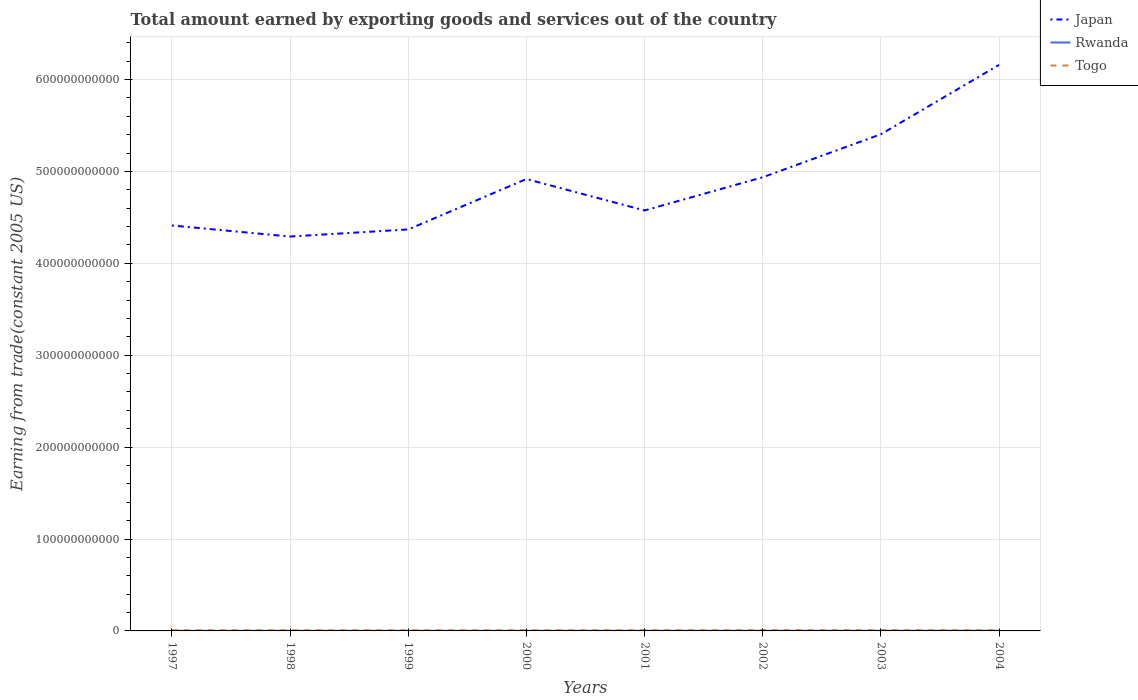How many different coloured lines are there?
Keep it short and to the point. 3. Is the number of lines equal to the number of legend labels?
Your answer should be very brief. Yes. Across all years, what is the maximum total amount earned by exporting goods and services in Togo?
Your response must be concise. 7.16e+08. What is the total total amount earned by exporting goods and services in Japan in the graph?
Your response must be concise. -5.68e+1. What is the difference between the highest and the second highest total amount earned by exporting goods and services in Rwanda?
Make the answer very short. 1.30e+08. Is the total amount earned by exporting goods and services in Rwanda strictly greater than the total amount earned by exporting goods and services in Japan over the years?
Provide a short and direct response. Yes. What is the difference between two consecutive major ticks on the Y-axis?
Provide a succinct answer. 1.00e+11. Does the graph contain grids?
Give a very brief answer. Yes. How are the legend labels stacked?
Offer a very short reply. Vertical. What is the title of the graph?
Offer a very short reply. Total amount earned by exporting goods and services out of the country. Does "Jordan" appear as one of the legend labels in the graph?
Keep it short and to the point. No. What is the label or title of the X-axis?
Keep it short and to the point. Years. What is the label or title of the Y-axis?
Offer a terse response. Earning from trade(constant 2005 US). What is the Earning from trade(constant 2005 US) of Japan in 1997?
Provide a succinct answer. 4.41e+11. What is the Earning from trade(constant 2005 US) of Rwanda in 1997?
Offer a very short reply. 7.58e+07. What is the Earning from trade(constant 2005 US) in Togo in 1997?
Provide a succinct answer. 7.65e+08. What is the Earning from trade(constant 2005 US) of Japan in 1998?
Give a very brief answer. 4.29e+11. What is the Earning from trade(constant 2005 US) in Rwanda in 1998?
Make the answer very short. 7.73e+07. What is the Earning from trade(constant 2005 US) of Togo in 1998?
Give a very brief answer. 7.56e+08. What is the Earning from trade(constant 2005 US) of Japan in 1999?
Offer a terse response. 4.37e+11. What is the Earning from trade(constant 2005 US) of Rwanda in 1999?
Your response must be concise. 9.19e+07. What is the Earning from trade(constant 2005 US) of Togo in 1999?
Give a very brief answer. 7.47e+08. What is the Earning from trade(constant 2005 US) in Japan in 2000?
Keep it short and to the point. 4.92e+11. What is the Earning from trade(constant 2005 US) of Rwanda in 2000?
Your response must be concise. 9.27e+07. What is the Earning from trade(constant 2005 US) of Togo in 2000?
Keep it short and to the point. 7.16e+08. What is the Earning from trade(constant 2005 US) of Japan in 2001?
Ensure brevity in your answer.  4.58e+11. What is the Earning from trade(constant 2005 US) of Rwanda in 2001?
Make the answer very short. 1.30e+08. What is the Earning from trade(constant 2005 US) of Togo in 2001?
Give a very brief answer. 7.79e+08. What is the Earning from trade(constant 2005 US) in Japan in 2002?
Offer a terse response. 4.94e+11. What is the Earning from trade(constant 2005 US) in Rwanda in 2002?
Keep it short and to the point. 1.36e+08. What is the Earning from trade(constant 2005 US) of Togo in 2002?
Keep it short and to the point. 8.73e+08. What is the Earning from trade(constant 2005 US) in Japan in 2003?
Give a very brief answer. 5.40e+11. What is the Earning from trade(constant 2005 US) in Rwanda in 2003?
Give a very brief answer. 1.57e+08. What is the Earning from trade(constant 2005 US) in Togo in 2003?
Provide a succinct answer. 8.88e+08. What is the Earning from trade(constant 2005 US) in Japan in 2004?
Keep it short and to the point. 6.16e+11. What is the Earning from trade(constant 2005 US) of Rwanda in 2004?
Provide a short and direct response. 2.06e+08. What is the Earning from trade(constant 2005 US) in Togo in 2004?
Your answer should be very brief. 7.74e+08. Across all years, what is the maximum Earning from trade(constant 2005 US) in Japan?
Offer a terse response. 6.16e+11. Across all years, what is the maximum Earning from trade(constant 2005 US) of Rwanda?
Give a very brief answer. 2.06e+08. Across all years, what is the maximum Earning from trade(constant 2005 US) in Togo?
Keep it short and to the point. 8.88e+08. Across all years, what is the minimum Earning from trade(constant 2005 US) of Japan?
Ensure brevity in your answer.  4.29e+11. Across all years, what is the minimum Earning from trade(constant 2005 US) of Rwanda?
Your answer should be compact. 7.58e+07. Across all years, what is the minimum Earning from trade(constant 2005 US) of Togo?
Your answer should be compact. 7.16e+08. What is the total Earning from trade(constant 2005 US) in Japan in the graph?
Your answer should be compact. 3.91e+12. What is the total Earning from trade(constant 2005 US) of Rwanda in the graph?
Give a very brief answer. 9.67e+08. What is the total Earning from trade(constant 2005 US) in Togo in the graph?
Give a very brief answer. 6.30e+09. What is the difference between the Earning from trade(constant 2005 US) in Japan in 1997 and that in 1998?
Provide a short and direct response. 1.20e+1. What is the difference between the Earning from trade(constant 2005 US) in Rwanda in 1997 and that in 1998?
Give a very brief answer. -1.44e+06. What is the difference between the Earning from trade(constant 2005 US) of Togo in 1997 and that in 1998?
Offer a terse response. 8.41e+06. What is the difference between the Earning from trade(constant 2005 US) of Japan in 1997 and that in 1999?
Provide a short and direct response. 4.28e+09. What is the difference between the Earning from trade(constant 2005 US) of Rwanda in 1997 and that in 1999?
Give a very brief answer. -1.60e+07. What is the difference between the Earning from trade(constant 2005 US) in Togo in 1997 and that in 1999?
Your answer should be compact. 1.82e+07. What is the difference between the Earning from trade(constant 2005 US) of Japan in 1997 and that in 2000?
Provide a short and direct response. -5.06e+1. What is the difference between the Earning from trade(constant 2005 US) of Rwanda in 1997 and that in 2000?
Keep it short and to the point. -1.68e+07. What is the difference between the Earning from trade(constant 2005 US) of Togo in 1997 and that in 2000?
Ensure brevity in your answer.  4.89e+07. What is the difference between the Earning from trade(constant 2005 US) in Japan in 1997 and that in 2001?
Your answer should be compact. -1.64e+1. What is the difference between the Earning from trade(constant 2005 US) in Rwanda in 1997 and that in 2001?
Make the answer very short. -5.41e+07. What is the difference between the Earning from trade(constant 2005 US) in Togo in 1997 and that in 2001?
Ensure brevity in your answer.  -1.40e+07. What is the difference between the Earning from trade(constant 2005 US) in Japan in 1997 and that in 2002?
Make the answer very short. -5.25e+1. What is the difference between the Earning from trade(constant 2005 US) in Rwanda in 1997 and that in 2002?
Your response must be concise. -5.99e+07. What is the difference between the Earning from trade(constant 2005 US) of Togo in 1997 and that in 2002?
Provide a succinct answer. -1.09e+08. What is the difference between the Earning from trade(constant 2005 US) in Japan in 1997 and that in 2003?
Make the answer very short. -9.93e+1. What is the difference between the Earning from trade(constant 2005 US) of Rwanda in 1997 and that in 2003?
Provide a succinct answer. -8.16e+07. What is the difference between the Earning from trade(constant 2005 US) in Togo in 1997 and that in 2003?
Keep it short and to the point. -1.23e+08. What is the difference between the Earning from trade(constant 2005 US) in Japan in 1997 and that in 2004?
Offer a terse response. -1.75e+11. What is the difference between the Earning from trade(constant 2005 US) of Rwanda in 1997 and that in 2004?
Offer a terse response. -1.30e+08. What is the difference between the Earning from trade(constant 2005 US) of Togo in 1997 and that in 2004?
Give a very brief answer. -9.31e+06. What is the difference between the Earning from trade(constant 2005 US) in Japan in 1998 and that in 1999?
Make the answer very short. -7.73e+09. What is the difference between the Earning from trade(constant 2005 US) in Rwanda in 1998 and that in 1999?
Make the answer very short. -1.46e+07. What is the difference between the Earning from trade(constant 2005 US) of Togo in 1998 and that in 1999?
Provide a succinct answer. 9.83e+06. What is the difference between the Earning from trade(constant 2005 US) of Japan in 1998 and that in 2000?
Provide a succinct answer. -6.26e+1. What is the difference between the Earning from trade(constant 2005 US) in Rwanda in 1998 and that in 2000?
Offer a terse response. -1.54e+07. What is the difference between the Earning from trade(constant 2005 US) of Togo in 1998 and that in 2000?
Your answer should be compact. 4.04e+07. What is the difference between the Earning from trade(constant 2005 US) in Japan in 1998 and that in 2001?
Your answer should be compact. -2.84e+1. What is the difference between the Earning from trade(constant 2005 US) of Rwanda in 1998 and that in 2001?
Your answer should be very brief. -5.27e+07. What is the difference between the Earning from trade(constant 2005 US) in Togo in 1998 and that in 2001?
Give a very brief answer. -2.24e+07. What is the difference between the Earning from trade(constant 2005 US) of Japan in 1998 and that in 2002?
Ensure brevity in your answer.  -6.45e+1. What is the difference between the Earning from trade(constant 2005 US) in Rwanda in 1998 and that in 2002?
Make the answer very short. -5.85e+07. What is the difference between the Earning from trade(constant 2005 US) in Togo in 1998 and that in 2002?
Offer a very short reply. -1.17e+08. What is the difference between the Earning from trade(constant 2005 US) of Japan in 1998 and that in 2003?
Your answer should be very brief. -1.11e+11. What is the difference between the Earning from trade(constant 2005 US) of Rwanda in 1998 and that in 2003?
Ensure brevity in your answer.  -8.02e+07. What is the difference between the Earning from trade(constant 2005 US) of Togo in 1998 and that in 2003?
Provide a short and direct response. -1.32e+08. What is the difference between the Earning from trade(constant 2005 US) in Japan in 1998 and that in 2004?
Offer a terse response. -1.87e+11. What is the difference between the Earning from trade(constant 2005 US) in Rwanda in 1998 and that in 2004?
Offer a very short reply. -1.29e+08. What is the difference between the Earning from trade(constant 2005 US) in Togo in 1998 and that in 2004?
Keep it short and to the point. -1.77e+07. What is the difference between the Earning from trade(constant 2005 US) in Japan in 1999 and that in 2000?
Offer a terse response. -5.48e+1. What is the difference between the Earning from trade(constant 2005 US) in Rwanda in 1999 and that in 2000?
Offer a terse response. -8.00e+05. What is the difference between the Earning from trade(constant 2005 US) in Togo in 1999 and that in 2000?
Provide a short and direct response. 3.06e+07. What is the difference between the Earning from trade(constant 2005 US) of Japan in 1999 and that in 2001?
Keep it short and to the point. -2.07e+1. What is the difference between the Earning from trade(constant 2005 US) of Rwanda in 1999 and that in 2001?
Keep it short and to the point. -3.81e+07. What is the difference between the Earning from trade(constant 2005 US) in Togo in 1999 and that in 2001?
Give a very brief answer. -3.22e+07. What is the difference between the Earning from trade(constant 2005 US) of Japan in 1999 and that in 2002?
Ensure brevity in your answer.  -5.68e+1. What is the difference between the Earning from trade(constant 2005 US) of Rwanda in 1999 and that in 2002?
Ensure brevity in your answer.  -4.39e+07. What is the difference between the Earning from trade(constant 2005 US) of Togo in 1999 and that in 2002?
Keep it short and to the point. -1.27e+08. What is the difference between the Earning from trade(constant 2005 US) of Japan in 1999 and that in 2003?
Your answer should be compact. -1.04e+11. What is the difference between the Earning from trade(constant 2005 US) of Rwanda in 1999 and that in 2003?
Give a very brief answer. -6.56e+07. What is the difference between the Earning from trade(constant 2005 US) of Togo in 1999 and that in 2003?
Ensure brevity in your answer.  -1.42e+08. What is the difference between the Earning from trade(constant 2005 US) in Japan in 1999 and that in 2004?
Provide a short and direct response. -1.79e+11. What is the difference between the Earning from trade(constant 2005 US) in Rwanda in 1999 and that in 2004?
Give a very brief answer. -1.14e+08. What is the difference between the Earning from trade(constant 2005 US) of Togo in 1999 and that in 2004?
Keep it short and to the point. -2.76e+07. What is the difference between the Earning from trade(constant 2005 US) in Japan in 2000 and that in 2001?
Provide a succinct answer. 3.42e+1. What is the difference between the Earning from trade(constant 2005 US) of Rwanda in 2000 and that in 2001?
Give a very brief answer. -3.73e+07. What is the difference between the Earning from trade(constant 2005 US) in Togo in 2000 and that in 2001?
Your answer should be very brief. -6.28e+07. What is the difference between the Earning from trade(constant 2005 US) of Japan in 2000 and that in 2002?
Your response must be concise. -1.94e+09. What is the difference between the Earning from trade(constant 2005 US) in Rwanda in 2000 and that in 2002?
Make the answer very short. -4.31e+07. What is the difference between the Earning from trade(constant 2005 US) in Togo in 2000 and that in 2002?
Offer a terse response. -1.57e+08. What is the difference between the Earning from trade(constant 2005 US) of Japan in 2000 and that in 2003?
Ensure brevity in your answer.  -4.87e+1. What is the difference between the Earning from trade(constant 2005 US) of Rwanda in 2000 and that in 2003?
Give a very brief answer. -6.48e+07. What is the difference between the Earning from trade(constant 2005 US) in Togo in 2000 and that in 2003?
Give a very brief answer. -1.72e+08. What is the difference between the Earning from trade(constant 2005 US) in Japan in 2000 and that in 2004?
Offer a very short reply. -1.24e+11. What is the difference between the Earning from trade(constant 2005 US) in Rwanda in 2000 and that in 2004?
Provide a succinct answer. -1.13e+08. What is the difference between the Earning from trade(constant 2005 US) in Togo in 2000 and that in 2004?
Your answer should be compact. -5.82e+07. What is the difference between the Earning from trade(constant 2005 US) of Japan in 2001 and that in 2002?
Give a very brief answer. -3.61e+1. What is the difference between the Earning from trade(constant 2005 US) in Rwanda in 2001 and that in 2002?
Your answer should be very brief. -5.78e+06. What is the difference between the Earning from trade(constant 2005 US) of Togo in 2001 and that in 2002?
Give a very brief answer. -9.47e+07. What is the difference between the Earning from trade(constant 2005 US) of Japan in 2001 and that in 2003?
Provide a short and direct response. -8.29e+1. What is the difference between the Earning from trade(constant 2005 US) of Rwanda in 2001 and that in 2003?
Ensure brevity in your answer.  -2.75e+07. What is the difference between the Earning from trade(constant 2005 US) in Togo in 2001 and that in 2003?
Make the answer very short. -1.09e+08. What is the difference between the Earning from trade(constant 2005 US) in Japan in 2001 and that in 2004?
Offer a terse response. -1.58e+11. What is the difference between the Earning from trade(constant 2005 US) in Rwanda in 2001 and that in 2004?
Give a very brief answer. -7.60e+07. What is the difference between the Earning from trade(constant 2005 US) of Togo in 2001 and that in 2004?
Provide a succinct answer. 4.64e+06. What is the difference between the Earning from trade(constant 2005 US) in Japan in 2002 and that in 2003?
Give a very brief answer. -4.68e+1. What is the difference between the Earning from trade(constant 2005 US) of Rwanda in 2002 and that in 2003?
Your response must be concise. -2.17e+07. What is the difference between the Earning from trade(constant 2005 US) of Togo in 2002 and that in 2003?
Offer a very short reply. -1.47e+07. What is the difference between the Earning from trade(constant 2005 US) in Japan in 2002 and that in 2004?
Offer a very short reply. -1.22e+11. What is the difference between the Earning from trade(constant 2005 US) of Rwanda in 2002 and that in 2004?
Provide a succinct answer. -7.02e+07. What is the difference between the Earning from trade(constant 2005 US) of Togo in 2002 and that in 2004?
Give a very brief answer. 9.93e+07. What is the difference between the Earning from trade(constant 2005 US) of Japan in 2003 and that in 2004?
Provide a short and direct response. -7.55e+1. What is the difference between the Earning from trade(constant 2005 US) in Rwanda in 2003 and that in 2004?
Provide a succinct answer. -4.86e+07. What is the difference between the Earning from trade(constant 2005 US) of Togo in 2003 and that in 2004?
Provide a short and direct response. 1.14e+08. What is the difference between the Earning from trade(constant 2005 US) of Japan in 1997 and the Earning from trade(constant 2005 US) of Rwanda in 1998?
Offer a terse response. 4.41e+11. What is the difference between the Earning from trade(constant 2005 US) of Japan in 1997 and the Earning from trade(constant 2005 US) of Togo in 1998?
Your response must be concise. 4.40e+11. What is the difference between the Earning from trade(constant 2005 US) in Rwanda in 1997 and the Earning from trade(constant 2005 US) in Togo in 1998?
Your response must be concise. -6.81e+08. What is the difference between the Earning from trade(constant 2005 US) in Japan in 1997 and the Earning from trade(constant 2005 US) in Rwanda in 1999?
Your answer should be very brief. 4.41e+11. What is the difference between the Earning from trade(constant 2005 US) in Japan in 1997 and the Earning from trade(constant 2005 US) in Togo in 1999?
Give a very brief answer. 4.40e+11. What is the difference between the Earning from trade(constant 2005 US) in Rwanda in 1997 and the Earning from trade(constant 2005 US) in Togo in 1999?
Keep it short and to the point. -6.71e+08. What is the difference between the Earning from trade(constant 2005 US) in Japan in 1997 and the Earning from trade(constant 2005 US) in Rwanda in 2000?
Offer a terse response. 4.41e+11. What is the difference between the Earning from trade(constant 2005 US) of Japan in 1997 and the Earning from trade(constant 2005 US) of Togo in 2000?
Ensure brevity in your answer.  4.40e+11. What is the difference between the Earning from trade(constant 2005 US) of Rwanda in 1997 and the Earning from trade(constant 2005 US) of Togo in 2000?
Make the answer very short. -6.40e+08. What is the difference between the Earning from trade(constant 2005 US) of Japan in 1997 and the Earning from trade(constant 2005 US) of Rwanda in 2001?
Provide a short and direct response. 4.41e+11. What is the difference between the Earning from trade(constant 2005 US) of Japan in 1997 and the Earning from trade(constant 2005 US) of Togo in 2001?
Ensure brevity in your answer.  4.40e+11. What is the difference between the Earning from trade(constant 2005 US) of Rwanda in 1997 and the Earning from trade(constant 2005 US) of Togo in 2001?
Your response must be concise. -7.03e+08. What is the difference between the Earning from trade(constant 2005 US) in Japan in 1997 and the Earning from trade(constant 2005 US) in Rwanda in 2002?
Your answer should be very brief. 4.41e+11. What is the difference between the Earning from trade(constant 2005 US) of Japan in 1997 and the Earning from trade(constant 2005 US) of Togo in 2002?
Give a very brief answer. 4.40e+11. What is the difference between the Earning from trade(constant 2005 US) in Rwanda in 1997 and the Earning from trade(constant 2005 US) in Togo in 2002?
Make the answer very short. -7.98e+08. What is the difference between the Earning from trade(constant 2005 US) of Japan in 1997 and the Earning from trade(constant 2005 US) of Rwanda in 2003?
Offer a very short reply. 4.41e+11. What is the difference between the Earning from trade(constant 2005 US) in Japan in 1997 and the Earning from trade(constant 2005 US) in Togo in 2003?
Provide a succinct answer. 4.40e+11. What is the difference between the Earning from trade(constant 2005 US) in Rwanda in 1997 and the Earning from trade(constant 2005 US) in Togo in 2003?
Give a very brief answer. -8.12e+08. What is the difference between the Earning from trade(constant 2005 US) in Japan in 1997 and the Earning from trade(constant 2005 US) in Rwanda in 2004?
Keep it short and to the point. 4.41e+11. What is the difference between the Earning from trade(constant 2005 US) in Japan in 1997 and the Earning from trade(constant 2005 US) in Togo in 2004?
Provide a short and direct response. 4.40e+11. What is the difference between the Earning from trade(constant 2005 US) in Rwanda in 1997 and the Earning from trade(constant 2005 US) in Togo in 2004?
Offer a very short reply. -6.98e+08. What is the difference between the Earning from trade(constant 2005 US) of Japan in 1998 and the Earning from trade(constant 2005 US) of Rwanda in 1999?
Provide a short and direct response. 4.29e+11. What is the difference between the Earning from trade(constant 2005 US) in Japan in 1998 and the Earning from trade(constant 2005 US) in Togo in 1999?
Your response must be concise. 4.28e+11. What is the difference between the Earning from trade(constant 2005 US) of Rwanda in 1998 and the Earning from trade(constant 2005 US) of Togo in 1999?
Offer a very short reply. -6.69e+08. What is the difference between the Earning from trade(constant 2005 US) of Japan in 1998 and the Earning from trade(constant 2005 US) of Rwanda in 2000?
Make the answer very short. 4.29e+11. What is the difference between the Earning from trade(constant 2005 US) in Japan in 1998 and the Earning from trade(constant 2005 US) in Togo in 2000?
Your response must be concise. 4.28e+11. What is the difference between the Earning from trade(constant 2005 US) of Rwanda in 1998 and the Earning from trade(constant 2005 US) of Togo in 2000?
Provide a short and direct response. -6.39e+08. What is the difference between the Earning from trade(constant 2005 US) of Japan in 1998 and the Earning from trade(constant 2005 US) of Rwanda in 2001?
Offer a terse response. 4.29e+11. What is the difference between the Earning from trade(constant 2005 US) in Japan in 1998 and the Earning from trade(constant 2005 US) in Togo in 2001?
Your answer should be very brief. 4.28e+11. What is the difference between the Earning from trade(constant 2005 US) of Rwanda in 1998 and the Earning from trade(constant 2005 US) of Togo in 2001?
Offer a very short reply. -7.02e+08. What is the difference between the Earning from trade(constant 2005 US) of Japan in 1998 and the Earning from trade(constant 2005 US) of Rwanda in 2002?
Keep it short and to the point. 4.29e+11. What is the difference between the Earning from trade(constant 2005 US) of Japan in 1998 and the Earning from trade(constant 2005 US) of Togo in 2002?
Keep it short and to the point. 4.28e+11. What is the difference between the Earning from trade(constant 2005 US) of Rwanda in 1998 and the Earning from trade(constant 2005 US) of Togo in 2002?
Offer a very short reply. -7.96e+08. What is the difference between the Earning from trade(constant 2005 US) in Japan in 1998 and the Earning from trade(constant 2005 US) in Rwanda in 2003?
Provide a short and direct response. 4.29e+11. What is the difference between the Earning from trade(constant 2005 US) of Japan in 1998 and the Earning from trade(constant 2005 US) of Togo in 2003?
Ensure brevity in your answer.  4.28e+11. What is the difference between the Earning from trade(constant 2005 US) of Rwanda in 1998 and the Earning from trade(constant 2005 US) of Togo in 2003?
Offer a very short reply. -8.11e+08. What is the difference between the Earning from trade(constant 2005 US) in Japan in 1998 and the Earning from trade(constant 2005 US) in Rwanda in 2004?
Give a very brief answer. 4.29e+11. What is the difference between the Earning from trade(constant 2005 US) in Japan in 1998 and the Earning from trade(constant 2005 US) in Togo in 2004?
Your response must be concise. 4.28e+11. What is the difference between the Earning from trade(constant 2005 US) of Rwanda in 1998 and the Earning from trade(constant 2005 US) of Togo in 2004?
Provide a succinct answer. -6.97e+08. What is the difference between the Earning from trade(constant 2005 US) of Japan in 1999 and the Earning from trade(constant 2005 US) of Rwanda in 2000?
Offer a terse response. 4.37e+11. What is the difference between the Earning from trade(constant 2005 US) in Japan in 1999 and the Earning from trade(constant 2005 US) in Togo in 2000?
Your answer should be compact. 4.36e+11. What is the difference between the Earning from trade(constant 2005 US) in Rwanda in 1999 and the Earning from trade(constant 2005 US) in Togo in 2000?
Keep it short and to the point. -6.24e+08. What is the difference between the Earning from trade(constant 2005 US) in Japan in 1999 and the Earning from trade(constant 2005 US) in Rwanda in 2001?
Give a very brief answer. 4.37e+11. What is the difference between the Earning from trade(constant 2005 US) of Japan in 1999 and the Earning from trade(constant 2005 US) of Togo in 2001?
Your response must be concise. 4.36e+11. What is the difference between the Earning from trade(constant 2005 US) in Rwanda in 1999 and the Earning from trade(constant 2005 US) in Togo in 2001?
Your answer should be very brief. -6.87e+08. What is the difference between the Earning from trade(constant 2005 US) in Japan in 1999 and the Earning from trade(constant 2005 US) in Rwanda in 2002?
Offer a terse response. 4.37e+11. What is the difference between the Earning from trade(constant 2005 US) in Japan in 1999 and the Earning from trade(constant 2005 US) in Togo in 2002?
Offer a terse response. 4.36e+11. What is the difference between the Earning from trade(constant 2005 US) in Rwanda in 1999 and the Earning from trade(constant 2005 US) in Togo in 2002?
Offer a very short reply. -7.82e+08. What is the difference between the Earning from trade(constant 2005 US) of Japan in 1999 and the Earning from trade(constant 2005 US) of Rwanda in 2003?
Ensure brevity in your answer.  4.37e+11. What is the difference between the Earning from trade(constant 2005 US) of Japan in 1999 and the Earning from trade(constant 2005 US) of Togo in 2003?
Provide a short and direct response. 4.36e+11. What is the difference between the Earning from trade(constant 2005 US) in Rwanda in 1999 and the Earning from trade(constant 2005 US) in Togo in 2003?
Offer a terse response. -7.96e+08. What is the difference between the Earning from trade(constant 2005 US) in Japan in 1999 and the Earning from trade(constant 2005 US) in Rwanda in 2004?
Provide a short and direct response. 4.37e+11. What is the difference between the Earning from trade(constant 2005 US) in Japan in 1999 and the Earning from trade(constant 2005 US) in Togo in 2004?
Your response must be concise. 4.36e+11. What is the difference between the Earning from trade(constant 2005 US) of Rwanda in 1999 and the Earning from trade(constant 2005 US) of Togo in 2004?
Provide a succinct answer. -6.82e+08. What is the difference between the Earning from trade(constant 2005 US) in Japan in 2000 and the Earning from trade(constant 2005 US) in Rwanda in 2001?
Offer a very short reply. 4.92e+11. What is the difference between the Earning from trade(constant 2005 US) of Japan in 2000 and the Earning from trade(constant 2005 US) of Togo in 2001?
Give a very brief answer. 4.91e+11. What is the difference between the Earning from trade(constant 2005 US) of Rwanda in 2000 and the Earning from trade(constant 2005 US) of Togo in 2001?
Ensure brevity in your answer.  -6.86e+08. What is the difference between the Earning from trade(constant 2005 US) of Japan in 2000 and the Earning from trade(constant 2005 US) of Rwanda in 2002?
Keep it short and to the point. 4.92e+11. What is the difference between the Earning from trade(constant 2005 US) of Japan in 2000 and the Earning from trade(constant 2005 US) of Togo in 2002?
Your response must be concise. 4.91e+11. What is the difference between the Earning from trade(constant 2005 US) in Rwanda in 2000 and the Earning from trade(constant 2005 US) in Togo in 2002?
Your response must be concise. -7.81e+08. What is the difference between the Earning from trade(constant 2005 US) in Japan in 2000 and the Earning from trade(constant 2005 US) in Rwanda in 2003?
Your response must be concise. 4.92e+11. What is the difference between the Earning from trade(constant 2005 US) in Japan in 2000 and the Earning from trade(constant 2005 US) in Togo in 2003?
Offer a terse response. 4.91e+11. What is the difference between the Earning from trade(constant 2005 US) in Rwanda in 2000 and the Earning from trade(constant 2005 US) in Togo in 2003?
Provide a succinct answer. -7.95e+08. What is the difference between the Earning from trade(constant 2005 US) of Japan in 2000 and the Earning from trade(constant 2005 US) of Rwanda in 2004?
Your answer should be compact. 4.92e+11. What is the difference between the Earning from trade(constant 2005 US) of Japan in 2000 and the Earning from trade(constant 2005 US) of Togo in 2004?
Ensure brevity in your answer.  4.91e+11. What is the difference between the Earning from trade(constant 2005 US) of Rwanda in 2000 and the Earning from trade(constant 2005 US) of Togo in 2004?
Your response must be concise. -6.81e+08. What is the difference between the Earning from trade(constant 2005 US) in Japan in 2001 and the Earning from trade(constant 2005 US) in Rwanda in 2002?
Provide a short and direct response. 4.57e+11. What is the difference between the Earning from trade(constant 2005 US) of Japan in 2001 and the Earning from trade(constant 2005 US) of Togo in 2002?
Offer a terse response. 4.57e+11. What is the difference between the Earning from trade(constant 2005 US) of Rwanda in 2001 and the Earning from trade(constant 2005 US) of Togo in 2002?
Provide a short and direct response. -7.43e+08. What is the difference between the Earning from trade(constant 2005 US) in Japan in 2001 and the Earning from trade(constant 2005 US) in Rwanda in 2003?
Give a very brief answer. 4.57e+11. What is the difference between the Earning from trade(constant 2005 US) in Japan in 2001 and the Earning from trade(constant 2005 US) in Togo in 2003?
Provide a short and direct response. 4.57e+11. What is the difference between the Earning from trade(constant 2005 US) of Rwanda in 2001 and the Earning from trade(constant 2005 US) of Togo in 2003?
Ensure brevity in your answer.  -7.58e+08. What is the difference between the Earning from trade(constant 2005 US) in Japan in 2001 and the Earning from trade(constant 2005 US) in Rwanda in 2004?
Offer a very short reply. 4.57e+11. What is the difference between the Earning from trade(constant 2005 US) of Japan in 2001 and the Earning from trade(constant 2005 US) of Togo in 2004?
Provide a succinct answer. 4.57e+11. What is the difference between the Earning from trade(constant 2005 US) of Rwanda in 2001 and the Earning from trade(constant 2005 US) of Togo in 2004?
Make the answer very short. -6.44e+08. What is the difference between the Earning from trade(constant 2005 US) in Japan in 2002 and the Earning from trade(constant 2005 US) in Rwanda in 2003?
Your response must be concise. 4.93e+11. What is the difference between the Earning from trade(constant 2005 US) in Japan in 2002 and the Earning from trade(constant 2005 US) in Togo in 2003?
Provide a succinct answer. 4.93e+11. What is the difference between the Earning from trade(constant 2005 US) in Rwanda in 2002 and the Earning from trade(constant 2005 US) in Togo in 2003?
Provide a succinct answer. -7.52e+08. What is the difference between the Earning from trade(constant 2005 US) in Japan in 2002 and the Earning from trade(constant 2005 US) in Rwanda in 2004?
Make the answer very short. 4.93e+11. What is the difference between the Earning from trade(constant 2005 US) of Japan in 2002 and the Earning from trade(constant 2005 US) of Togo in 2004?
Keep it short and to the point. 4.93e+11. What is the difference between the Earning from trade(constant 2005 US) in Rwanda in 2002 and the Earning from trade(constant 2005 US) in Togo in 2004?
Offer a terse response. -6.38e+08. What is the difference between the Earning from trade(constant 2005 US) in Japan in 2003 and the Earning from trade(constant 2005 US) in Rwanda in 2004?
Your answer should be very brief. 5.40e+11. What is the difference between the Earning from trade(constant 2005 US) in Japan in 2003 and the Earning from trade(constant 2005 US) in Togo in 2004?
Provide a succinct answer. 5.40e+11. What is the difference between the Earning from trade(constant 2005 US) in Rwanda in 2003 and the Earning from trade(constant 2005 US) in Togo in 2004?
Keep it short and to the point. -6.17e+08. What is the average Earning from trade(constant 2005 US) in Japan per year?
Your response must be concise. 4.88e+11. What is the average Earning from trade(constant 2005 US) in Rwanda per year?
Your answer should be compact. 1.21e+08. What is the average Earning from trade(constant 2005 US) of Togo per year?
Provide a short and direct response. 7.87e+08. In the year 1997, what is the difference between the Earning from trade(constant 2005 US) of Japan and Earning from trade(constant 2005 US) of Rwanda?
Make the answer very short. 4.41e+11. In the year 1997, what is the difference between the Earning from trade(constant 2005 US) in Japan and Earning from trade(constant 2005 US) in Togo?
Your answer should be very brief. 4.40e+11. In the year 1997, what is the difference between the Earning from trade(constant 2005 US) of Rwanda and Earning from trade(constant 2005 US) of Togo?
Provide a succinct answer. -6.89e+08. In the year 1998, what is the difference between the Earning from trade(constant 2005 US) of Japan and Earning from trade(constant 2005 US) of Rwanda?
Your response must be concise. 4.29e+11. In the year 1998, what is the difference between the Earning from trade(constant 2005 US) of Japan and Earning from trade(constant 2005 US) of Togo?
Your response must be concise. 4.28e+11. In the year 1998, what is the difference between the Earning from trade(constant 2005 US) of Rwanda and Earning from trade(constant 2005 US) of Togo?
Your response must be concise. -6.79e+08. In the year 1999, what is the difference between the Earning from trade(constant 2005 US) of Japan and Earning from trade(constant 2005 US) of Rwanda?
Keep it short and to the point. 4.37e+11. In the year 1999, what is the difference between the Earning from trade(constant 2005 US) in Japan and Earning from trade(constant 2005 US) in Togo?
Give a very brief answer. 4.36e+11. In the year 1999, what is the difference between the Earning from trade(constant 2005 US) in Rwanda and Earning from trade(constant 2005 US) in Togo?
Your answer should be very brief. -6.55e+08. In the year 2000, what is the difference between the Earning from trade(constant 2005 US) of Japan and Earning from trade(constant 2005 US) of Rwanda?
Offer a terse response. 4.92e+11. In the year 2000, what is the difference between the Earning from trade(constant 2005 US) of Japan and Earning from trade(constant 2005 US) of Togo?
Keep it short and to the point. 4.91e+11. In the year 2000, what is the difference between the Earning from trade(constant 2005 US) of Rwanda and Earning from trade(constant 2005 US) of Togo?
Your response must be concise. -6.23e+08. In the year 2001, what is the difference between the Earning from trade(constant 2005 US) of Japan and Earning from trade(constant 2005 US) of Rwanda?
Your answer should be compact. 4.57e+11. In the year 2001, what is the difference between the Earning from trade(constant 2005 US) in Japan and Earning from trade(constant 2005 US) in Togo?
Your response must be concise. 4.57e+11. In the year 2001, what is the difference between the Earning from trade(constant 2005 US) of Rwanda and Earning from trade(constant 2005 US) of Togo?
Offer a terse response. -6.49e+08. In the year 2002, what is the difference between the Earning from trade(constant 2005 US) in Japan and Earning from trade(constant 2005 US) in Rwanda?
Offer a terse response. 4.94e+11. In the year 2002, what is the difference between the Earning from trade(constant 2005 US) of Japan and Earning from trade(constant 2005 US) of Togo?
Provide a short and direct response. 4.93e+11. In the year 2002, what is the difference between the Earning from trade(constant 2005 US) of Rwanda and Earning from trade(constant 2005 US) of Togo?
Offer a very short reply. -7.38e+08. In the year 2003, what is the difference between the Earning from trade(constant 2005 US) of Japan and Earning from trade(constant 2005 US) of Rwanda?
Provide a short and direct response. 5.40e+11. In the year 2003, what is the difference between the Earning from trade(constant 2005 US) in Japan and Earning from trade(constant 2005 US) in Togo?
Your response must be concise. 5.40e+11. In the year 2003, what is the difference between the Earning from trade(constant 2005 US) in Rwanda and Earning from trade(constant 2005 US) in Togo?
Ensure brevity in your answer.  -7.31e+08. In the year 2004, what is the difference between the Earning from trade(constant 2005 US) in Japan and Earning from trade(constant 2005 US) in Rwanda?
Provide a succinct answer. 6.16e+11. In the year 2004, what is the difference between the Earning from trade(constant 2005 US) in Japan and Earning from trade(constant 2005 US) in Togo?
Give a very brief answer. 6.15e+11. In the year 2004, what is the difference between the Earning from trade(constant 2005 US) of Rwanda and Earning from trade(constant 2005 US) of Togo?
Offer a very short reply. -5.68e+08. What is the ratio of the Earning from trade(constant 2005 US) in Japan in 1997 to that in 1998?
Your answer should be compact. 1.03. What is the ratio of the Earning from trade(constant 2005 US) in Rwanda in 1997 to that in 1998?
Make the answer very short. 0.98. What is the ratio of the Earning from trade(constant 2005 US) in Togo in 1997 to that in 1998?
Ensure brevity in your answer.  1.01. What is the ratio of the Earning from trade(constant 2005 US) in Japan in 1997 to that in 1999?
Give a very brief answer. 1.01. What is the ratio of the Earning from trade(constant 2005 US) in Rwanda in 1997 to that in 1999?
Offer a very short reply. 0.83. What is the ratio of the Earning from trade(constant 2005 US) of Togo in 1997 to that in 1999?
Offer a very short reply. 1.02. What is the ratio of the Earning from trade(constant 2005 US) in Japan in 1997 to that in 2000?
Ensure brevity in your answer.  0.9. What is the ratio of the Earning from trade(constant 2005 US) of Rwanda in 1997 to that in 2000?
Offer a very short reply. 0.82. What is the ratio of the Earning from trade(constant 2005 US) of Togo in 1997 to that in 2000?
Keep it short and to the point. 1.07. What is the ratio of the Earning from trade(constant 2005 US) of Japan in 1997 to that in 2001?
Provide a succinct answer. 0.96. What is the ratio of the Earning from trade(constant 2005 US) of Rwanda in 1997 to that in 2001?
Ensure brevity in your answer.  0.58. What is the ratio of the Earning from trade(constant 2005 US) in Togo in 1997 to that in 2001?
Offer a terse response. 0.98. What is the ratio of the Earning from trade(constant 2005 US) of Japan in 1997 to that in 2002?
Keep it short and to the point. 0.89. What is the ratio of the Earning from trade(constant 2005 US) of Rwanda in 1997 to that in 2002?
Offer a terse response. 0.56. What is the ratio of the Earning from trade(constant 2005 US) of Togo in 1997 to that in 2002?
Provide a short and direct response. 0.88. What is the ratio of the Earning from trade(constant 2005 US) in Japan in 1997 to that in 2003?
Give a very brief answer. 0.82. What is the ratio of the Earning from trade(constant 2005 US) of Rwanda in 1997 to that in 2003?
Your answer should be compact. 0.48. What is the ratio of the Earning from trade(constant 2005 US) in Togo in 1997 to that in 2003?
Offer a terse response. 0.86. What is the ratio of the Earning from trade(constant 2005 US) in Japan in 1997 to that in 2004?
Your answer should be compact. 0.72. What is the ratio of the Earning from trade(constant 2005 US) in Rwanda in 1997 to that in 2004?
Give a very brief answer. 0.37. What is the ratio of the Earning from trade(constant 2005 US) in Japan in 1998 to that in 1999?
Your answer should be compact. 0.98. What is the ratio of the Earning from trade(constant 2005 US) in Rwanda in 1998 to that in 1999?
Give a very brief answer. 0.84. What is the ratio of the Earning from trade(constant 2005 US) of Togo in 1998 to that in 1999?
Keep it short and to the point. 1.01. What is the ratio of the Earning from trade(constant 2005 US) of Japan in 1998 to that in 2000?
Keep it short and to the point. 0.87. What is the ratio of the Earning from trade(constant 2005 US) in Rwanda in 1998 to that in 2000?
Ensure brevity in your answer.  0.83. What is the ratio of the Earning from trade(constant 2005 US) of Togo in 1998 to that in 2000?
Provide a succinct answer. 1.06. What is the ratio of the Earning from trade(constant 2005 US) in Japan in 1998 to that in 2001?
Offer a terse response. 0.94. What is the ratio of the Earning from trade(constant 2005 US) in Rwanda in 1998 to that in 2001?
Your answer should be very brief. 0.59. What is the ratio of the Earning from trade(constant 2005 US) in Togo in 1998 to that in 2001?
Ensure brevity in your answer.  0.97. What is the ratio of the Earning from trade(constant 2005 US) of Japan in 1998 to that in 2002?
Ensure brevity in your answer.  0.87. What is the ratio of the Earning from trade(constant 2005 US) in Rwanda in 1998 to that in 2002?
Keep it short and to the point. 0.57. What is the ratio of the Earning from trade(constant 2005 US) of Togo in 1998 to that in 2002?
Make the answer very short. 0.87. What is the ratio of the Earning from trade(constant 2005 US) of Japan in 1998 to that in 2003?
Keep it short and to the point. 0.79. What is the ratio of the Earning from trade(constant 2005 US) in Rwanda in 1998 to that in 2003?
Give a very brief answer. 0.49. What is the ratio of the Earning from trade(constant 2005 US) in Togo in 1998 to that in 2003?
Your answer should be compact. 0.85. What is the ratio of the Earning from trade(constant 2005 US) of Japan in 1998 to that in 2004?
Offer a terse response. 0.7. What is the ratio of the Earning from trade(constant 2005 US) in Rwanda in 1998 to that in 2004?
Make the answer very short. 0.38. What is the ratio of the Earning from trade(constant 2005 US) of Togo in 1998 to that in 2004?
Keep it short and to the point. 0.98. What is the ratio of the Earning from trade(constant 2005 US) of Japan in 1999 to that in 2000?
Your answer should be very brief. 0.89. What is the ratio of the Earning from trade(constant 2005 US) of Togo in 1999 to that in 2000?
Offer a very short reply. 1.04. What is the ratio of the Earning from trade(constant 2005 US) of Japan in 1999 to that in 2001?
Provide a succinct answer. 0.95. What is the ratio of the Earning from trade(constant 2005 US) in Rwanda in 1999 to that in 2001?
Provide a short and direct response. 0.71. What is the ratio of the Earning from trade(constant 2005 US) in Togo in 1999 to that in 2001?
Give a very brief answer. 0.96. What is the ratio of the Earning from trade(constant 2005 US) of Japan in 1999 to that in 2002?
Make the answer very short. 0.89. What is the ratio of the Earning from trade(constant 2005 US) of Rwanda in 1999 to that in 2002?
Your answer should be very brief. 0.68. What is the ratio of the Earning from trade(constant 2005 US) of Togo in 1999 to that in 2002?
Give a very brief answer. 0.85. What is the ratio of the Earning from trade(constant 2005 US) of Japan in 1999 to that in 2003?
Your answer should be compact. 0.81. What is the ratio of the Earning from trade(constant 2005 US) of Rwanda in 1999 to that in 2003?
Make the answer very short. 0.58. What is the ratio of the Earning from trade(constant 2005 US) of Togo in 1999 to that in 2003?
Make the answer very short. 0.84. What is the ratio of the Earning from trade(constant 2005 US) of Japan in 1999 to that in 2004?
Provide a short and direct response. 0.71. What is the ratio of the Earning from trade(constant 2005 US) in Rwanda in 1999 to that in 2004?
Make the answer very short. 0.45. What is the ratio of the Earning from trade(constant 2005 US) of Togo in 1999 to that in 2004?
Offer a very short reply. 0.96. What is the ratio of the Earning from trade(constant 2005 US) of Japan in 2000 to that in 2001?
Give a very brief answer. 1.07. What is the ratio of the Earning from trade(constant 2005 US) of Rwanda in 2000 to that in 2001?
Make the answer very short. 0.71. What is the ratio of the Earning from trade(constant 2005 US) of Togo in 2000 to that in 2001?
Offer a very short reply. 0.92. What is the ratio of the Earning from trade(constant 2005 US) of Japan in 2000 to that in 2002?
Your answer should be compact. 1. What is the ratio of the Earning from trade(constant 2005 US) in Rwanda in 2000 to that in 2002?
Provide a succinct answer. 0.68. What is the ratio of the Earning from trade(constant 2005 US) in Togo in 2000 to that in 2002?
Keep it short and to the point. 0.82. What is the ratio of the Earning from trade(constant 2005 US) of Japan in 2000 to that in 2003?
Provide a succinct answer. 0.91. What is the ratio of the Earning from trade(constant 2005 US) in Rwanda in 2000 to that in 2003?
Your response must be concise. 0.59. What is the ratio of the Earning from trade(constant 2005 US) in Togo in 2000 to that in 2003?
Your response must be concise. 0.81. What is the ratio of the Earning from trade(constant 2005 US) of Japan in 2000 to that in 2004?
Offer a very short reply. 0.8. What is the ratio of the Earning from trade(constant 2005 US) in Rwanda in 2000 to that in 2004?
Offer a terse response. 0.45. What is the ratio of the Earning from trade(constant 2005 US) in Togo in 2000 to that in 2004?
Your answer should be compact. 0.92. What is the ratio of the Earning from trade(constant 2005 US) in Japan in 2001 to that in 2002?
Your answer should be compact. 0.93. What is the ratio of the Earning from trade(constant 2005 US) in Rwanda in 2001 to that in 2002?
Offer a terse response. 0.96. What is the ratio of the Earning from trade(constant 2005 US) in Togo in 2001 to that in 2002?
Your answer should be compact. 0.89. What is the ratio of the Earning from trade(constant 2005 US) of Japan in 2001 to that in 2003?
Offer a terse response. 0.85. What is the ratio of the Earning from trade(constant 2005 US) in Rwanda in 2001 to that in 2003?
Offer a very short reply. 0.83. What is the ratio of the Earning from trade(constant 2005 US) of Togo in 2001 to that in 2003?
Your response must be concise. 0.88. What is the ratio of the Earning from trade(constant 2005 US) in Japan in 2001 to that in 2004?
Make the answer very short. 0.74. What is the ratio of the Earning from trade(constant 2005 US) of Rwanda in 2001 to that in 2004?
Your answer should be very brief. 0.63. What is the ratio of the Earning from trade(constant 2005 US) of Japan in 2002 to that in 2003?
Offer a very short reply. 0.91. What is the ratio of the Earning from trade(constant 2005 US) of Rwanda in 2002 to that in 2003?
Offer a very short reply. 0.86. What is the ratio of the Earning from trade(constant 2005 US) of Togo in 2002 to that in 2003?
Give a very brief answer. 0.98. What is the ratio of the Earning from trade(constant 2005 US) of Japan in 2002 to that in 2004?
Your response must be concise. 0.8. What is the ratio of the Earning from trade(constant 2005 US) in Rwanda in 2002 to that in 2004?
Keep it short and to the point. 0.66. What is the ratio of the Earning from trade(constant 2005 US) of Togo in 2002 to that in 2004?
Ensure brevity in your answer.  1.13. What is the ratio of the Earning from trade(constant 2005 US) in Japan in 2003 to that in 2004?
Give a very brief answer. 0.88. What is the ratio of the Earning from trade(constant 2005 US) of Rwanda in 2003 to that in 2004?
Your answer should be compact. 0.76. What is the ratio of the Earning from trade(constant 2005 US) in Togo in 2003 to that in 2004?
Ensure brevity in your answer.  1.15. What is the difference between the highest and the second highest Earning from trade(constant 2005 US) of Japan?
Ensure brevity in your answer.  7.55e+1. What is the difference between the highest and the second highest Earning from trade(constant 2005 US) of Rwanda?
Your answer should be very brief. 4.86e+07. What is the difference between the highest and the second highest Earning from trade(constant 2005 US) in Togo?
Your answer should be very brief. 1.47e+07. What is the difference between the highest and the lowest Earning from trade(constant 2005 US) in Japan?
Ensure brevity in your answer.  1.87e+11. What is the difference between the highest and the lowest Earning from trade(constant 2005 US) of Rwanda?
Offer a terse response. 1.30e+08. What is the difference between the highest and the lowest Earning from trade(constant 2005 US) in Togo?
Your response must be concise. 1.72e+08. 